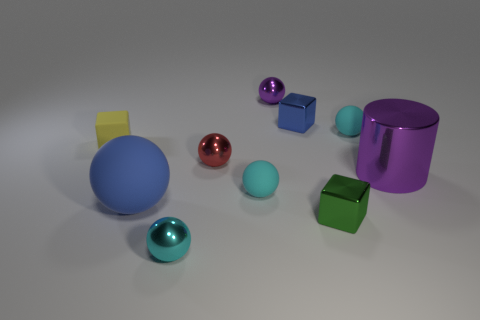What number of other objects are the same size as the cyan metallic object?
Make the answer very short. 7. The tiny metallic sphere right of the tiny cyan matte sphere that is on the left side of the tiny cyan matte sphere that is behind the tiny yellow thing is what color?
Ensure brevity in your answer.  Purple. How many other objects are there of the same shape as the small green object?
Your response must be concise. 2. What is the shape of the blue object in front of the small yellow thing?
Provide a succinct answer. Sphere. Are there any small cubes that are behind the cyan object that is to the right of the small purple thing?
Give a very brief answer. Yes. There is a matte thing that is behind the red object and left of the tiny cyan shiny thing; what color is it?
Keep it short and to the point. Yellow. There is a small cyan matte thing right of the purple thing that is on the left side of the purple shiny cylinder; are there any small cyan rubber things that are on the left side of it?
Your response must be concise. Yes. There is a yellow object that is the same shape as the small green object; what size is it?
Keep it short and to the point. Small. Is there anything else that has the same material as the yellow cube?
Keep it short and to the point. Yes. Are any big green shiny cylinders visible?
Ensure brevity in your answer.  No. 